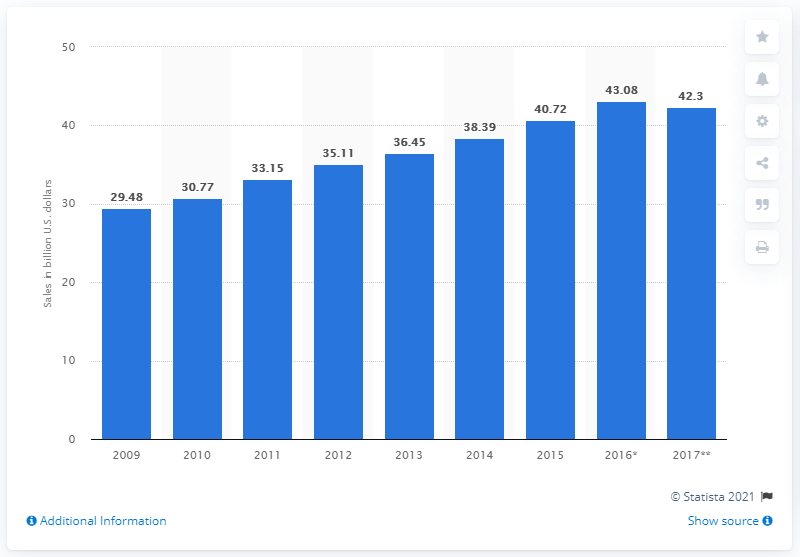List a handful of essential elements in this visual. The sales of retail-host restaurants in 2017 were expected to be approximately 42.3. 